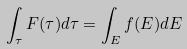<formula> <loc_0><loc_0><loc_500><loc_500>\int _ { \tau } F ( \tau ) d \tau = \int _ { E } f ( E ) d E</formula> 